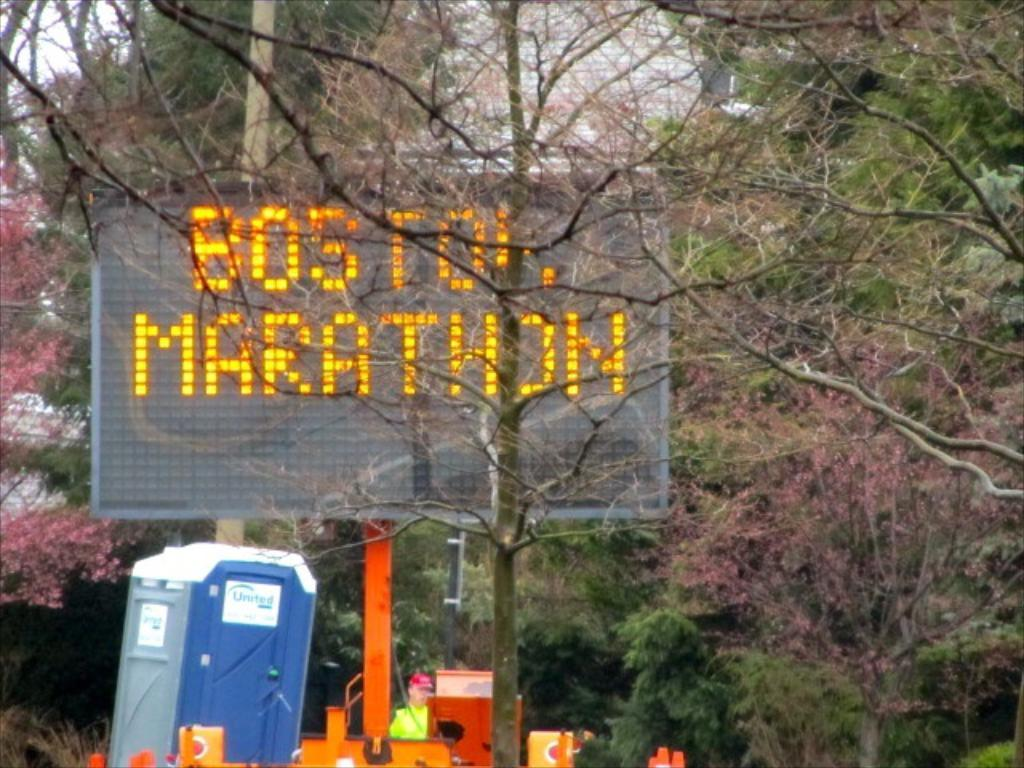<image>
Share a concise interpretation of the image provided. A large street sign that reads BOSTON MARATHON. 